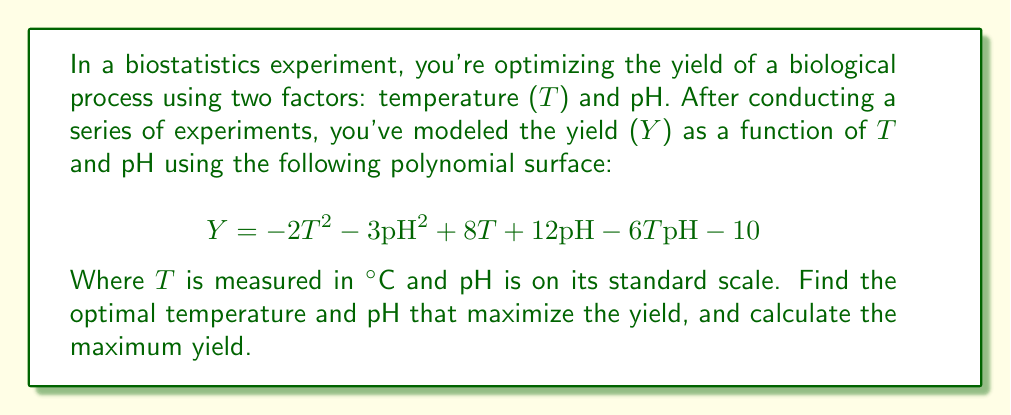Help me with this question. To find the optimal temperature and pH that maximize the yield, we need to find the critical points of the polynomial surface. This involves taking partial derivatives with respect to T and pH, setting them equal to zero, and solving the resulting system of equations.

1. Take partial derivatives:
   $$\frac{\partial Y}{\partial T} = -4T + 8 - 6pH$$
   $$\frac{\partial Y}{\partial pH} = -6pH + 12 - 6T$$

2. Set both partial derivatives to zero and solve the system of equations:
   $$-4T + 8 - 6pH = 0$$
   $$-6pH + 12 - 6T = 0$$

3. From the second equation:
   $$pH = 2 - T$$

4. Substitute this into the first equation:
   $$-4T + 8 - 6(2 - T) = 0$$
   $$-4T + 8 - 12 + 6T = 0$$
   $$2T - 4 = 0$$
   $$T = 2$$

5. Substitute T = 2 back into the equation from step 3:
   $$pH = 2 - 2 = 0$$

6. To confirm this is a maximum, we can check the second partial derivatives:
   $$\frac{\partial^2 Y}{\partial T^2} = -4$$
   $$\frac{\partial^2 Y}{\partial pH^2} = -6$$
   $$\frac{\partial^2 Y}{\partial T \partial pH} = -6$$

   The Hessian matrix is:
   $$H = \begin{bmatrix} -4 & -6 \\ -6 & -6 \end{bmatrix}$$

   The determinant of H is positive (24 - 36 = -12), and the trace is negative (-4 - 6 = -10), confirming a local maximum.

7. Calculate the maximum yield by substituting T = 2 and pH = 0 into the original equation:
   $$Y = -2(2)^2 - 3(0)^2 + 8(2) + 12(0) - 6(2)(0) - 10$$
   $$Y = -8 + 16 - 10 = -2$$
Answer: The optimal temperature is 2°C, the optimal pH is 0, and the maximum yield is -2 units. 